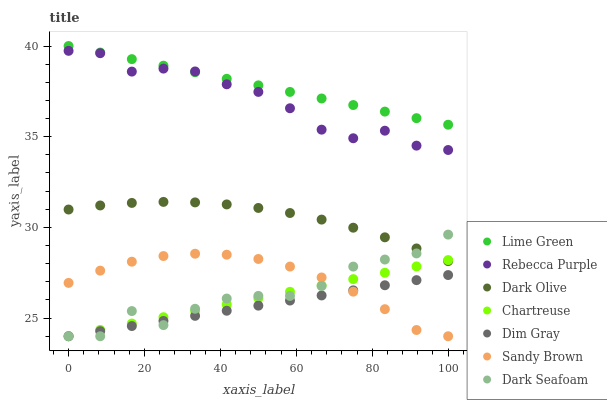Does Dim Gray have the minimum area under the curve?
Answer yes or no. Yes. Does Lime Green have the maximum area under the curve?
Answer yes or no. Yes. Does Dark Olive have the minimum area under the curve?
Answer yes or no. No. Does Dark Olive have the maximum area under the curve?
Answer yes or no. No. Is Dim Gray the smoothest?
Answer yes or no. Yes. Is Dark Seafoam the roughest?
Answer yes or no. Yes. Is Lime Green the smoothest?
Answer yes or no. No. Is Lime Green the roughest?
Answer yes or no. No. Does Dim Gray have the lowest value?
Answer yes or no. Yes. Does Dark Olive have the lowest value?
Answer yes or no. No. Does Lime Green have the highest value?
Answer yes or no. Yes. Does Dark Olive have the highest value?
Answer yes or no. No. Is Dark Olive less than Lime Green?
Answer yes or no. Yes. Is Lime Green greater than Dark Olive?
Answer yes or no. Yes. Does Sandy Brown intersect Dark Seafoam?
Answer yes or no. Yes. Is Sandy Brown less than Dark Seafoam?
Answer yes or no. No. Is Sandy Brown greater than Dark Seafoam?
Answer yes or no. No. Does Dark Olive intersect Lime Green?
Answer yes or no. No. 